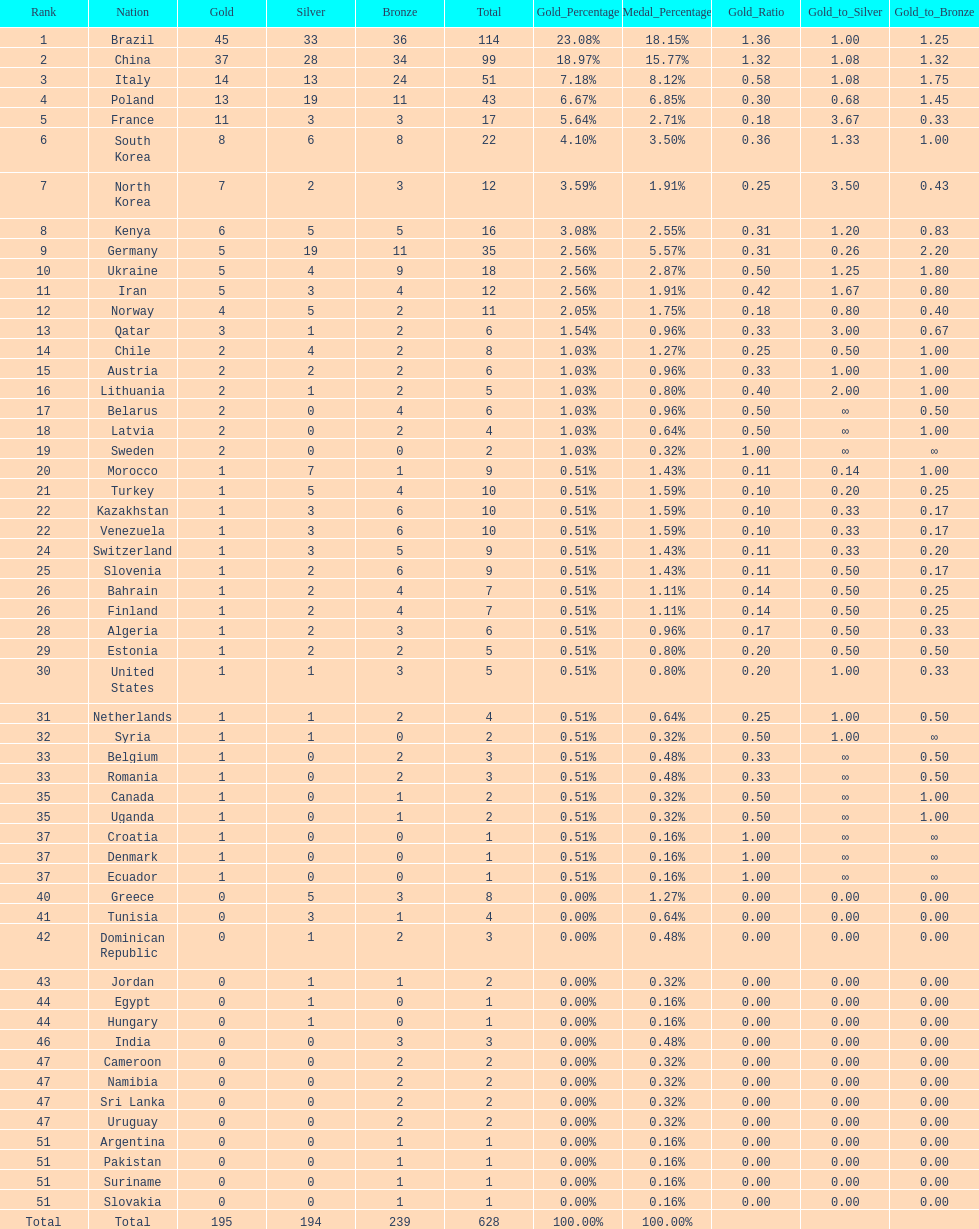Would you be able to parse every entry in this table? {'header': ['Rank', 'Nation', 'Gold', 'Silver', 'Bronze', 'Total', 'Gold_Percentage', 'Medal_Percentage', 'Gold_Ratio', 'Gold_to_Silver', 'Gold_to_Bronze'], 'rows': [['1', 'Brazil', '45', '33', '36', '114', '23.08%', '18.15%', '1.36', '1.00', '1.25'], ['2', 'China', '37', '28', '34', '99', '18.97%', '15.77%', '1.32', '1.08', '1.32'], ['3', 'Italy', '14', '13', '24', '51', '7.18%', '8.12%', '0.58', '1.08', '1.75'], ['4', 'Poland', '13', '19', '11', '43', '6.67%', '6.85%', '0.30', '0.68', '1.45'], ['5', 'France', '11', '3', '3', '17', '5.64%', '2.71%', '0.18', '3.67', '0.33'], ['6', 'South Korea', '8', '6', '8', '22', '4.10%', '3.50%', '0.36', '1.33', '1.00'], ['7', 'North Korea', '7', '2', '3', '12', '3.59%', '1.91%', '0.25', '3.50', '0.43'], ['8', 'Kenya', '6', '5', '5', '16', '3.08%', '2.55%', '0.31', '1.20', '0.83'], ['9', 'Germany', '5', '19', '11', '35', '2.56%', '5.57%', '0.31', '0.26', '2.20'], ['10', 'Ukraine', '5', '4', '9', '18', '2.56%', '2.87%', '0.50', '1.25', '1.80'], ['11', 'Iran', '5', '3', '4', '12', '2.56%', '1.91%', '0.42', '1.67', '0.80'], ['12', 'Norway', '4', '5', '2', '11', '2.05%', '1.75%', '0.18', '0.80', '0.40'], ['13', 'Qatar', '3', '1', '2', '6', '1.54%', '0.96%', '0.33', '3.00', '0.67'], ['14', 'Chile', '2', '4', '2', '8', '1.03%', '1.27%', '0.25', '0.50', '1.00'], ['15', 'Austria', '2', '2', '2', '6', '1.03%', '0.96%', '0.33', '1.00', '1.00'], ['16', 'Lithuania', '2', '1', '2', '5', '1.03%', '0.80%', '0.40', '2.00', '1.00'], ['17', 'Belarus', '2', '0', '4', '6', '1.03%', '0.96%', '0.50', '∞', '0.50'], ['18', 'Latvia', '2', '0', '2', '4', '1.03%', '0.64%', '0.50', '∞', '1.00'], ['19', 'Sweden', '2', '0', '0', '2', '1.03%', '0.32%', '1.00', '∞', '∞'], ['20', 'Morocco', '1', '7', '1', '9', '0.51%', '1.43%', '0.11', '0.14', '1.00'], ['21', 'Turkey', '1', '5', '4', '10', '0.51%', '1.59%', '0.10', '0.20', '0.25'], ['22', 'Kazakhstan', '1', '3', '6', '10', '0.51%', '1.59%', '0.10', '0.33', '0.17'], ['22', 'Venezuela', '1', '3', '6', '10', '0.51%', '1.59%', '0.10', '0.33', '0.17'], ['24', 'Switzerland', '1', '3', '5', '9', '0.51%', '1.43%', '0.11', '0.33', '0.20'], ['25', 'Slovenia', '1', '2', '6', '9', '0.51%', '1.43%', '0.11', '0.50', '0.17'], ['26', 'Bahrain', '1', '2', '4', '7', '0.51%', '1.11%', '0.14', '0.50', '0.25'], ['26', 'Finland', '1', '2', '4', '7', '0.51%', '1.11%', '0.14', '0.50', '0.25'], ['28', 'Algeria', '1', '2', '3', '6', '0.51%', '0.96%', '0.17', '0.50', '0.33'], ['29', 'Estonia', '1', '2', '2', '5', '0.51%', '0.80%', '0.20', '0.50', '0.50'], ['30', 'United States', '1', '1', '3', '5', '0.51%', '0.80%', '0.20', '1.00', '0.33'], ['31', 'Netherlands', '1', '1', '2', '4', '0.51%', '0.64%', '0.25', '1.00', '0.50'], ['32', 'Syria', '1', '1', '0', '2', '0.51%', '0.32%', '0.50', '1.00', '∞'], ['33', 'Belgium', '1', '0', '2', '3', '0.51%', '0.48%', '0.33', '∞', '0.50'], ['33', 'Romania', '1', '0', '2', '3', '0.51%', '0.48%', '0.33', '∞', '0.50'], ['35', 'Canada', '1', '0', '1', '2', '0.51%', '0.32%', '0.50', '∞', '1.00'], ['35', 'Uganda', '1', '0', '1', '2', '0.51%', '0.32%', '0.50', '∞', '1.00'], ['37', 'Croatia', '1', '0', '0', '1', '0.51%', '0.16%', '1.00', '∞', '∞'], ['37', 'Denmark', '1', '0', '0', '1', '0.51%', '0.16%', '1.00', '∞', '∞'], ['37', 'Ecuador', '1', '0', '0', '1', '0.51%', '0.16%', '1.00', '∞', '∞'], ['40', 'Greece', '0', '5', '3', '8', '0.00%', '1.27%', '0.00', '0.00', '0.00'], ['41', 'Tunisia', '0', '3', '1', '4', '0.00%', '0.64%', '0.00', '0.00', '0.00'], ['42', 'Dominican Republic', '0', '1', '2', '3', '0.00%', '0.48%', '0.00', '0.00', '0.00'], ['43', 'Jordan', '0', '1', '1', '2', '0.00%', '0.32%', '0.00', '0.00', '0.00'], ['44', 'Egypt', '0', '1', '0', '1', '0.00%', '0.16%', '0.00', '0.00', '0.00'], ['44', 'Hungary', '0', '1', '0', '1', '0.00%', '0.16%', '0.00', '0.00', '0.00'], ['46', 'India', '0', '0', '3', '3', '0.00%', '0.48%', '0.00', '0.00', '0.00'], ['47', 'Cameroon', '0', '0', '2', '2', '0.00%', '0.32%', '0.00', '0.00', '0.00'], ['47', 'Namibia', '0', '0', '2', '2', '0.00%', '0.32%', '0.00', '0.00', '0.00'], ['47', 'Sri Lanka', '0', '0', '2', '2', '0.00%', '0.32%', '0.00', '0.00', '0.00'], ['47', 'Uruguay', '0', '0', '2', '2', '0.00%', '0.32%', '0.00', '0.00', '0.00'], ['51', 'Argentina', '0', '0', '1', '1', '0.00%', '0.16%', '0.00', '0.00', '0.00'], ['51', 'Pakistan', '0', '0', '1', '1', '0.00%', '0.16%', '0.00', '0.00', '0.00'], ['51', 'Suriname', '0', '0', '1', '1', '0.00%', '0.16%', '0.00', '0.00', '0.00'], ['51', 'Slovakia', '0', '0', '1', '1', '0.00%', '0.16%', '0.00', '0.00', '0.00'], ['Total', 'Total', '195', '194', '239', '628', '100.00%', '100.00%', '', '', '']]} How many total medals did norway win? 11. 